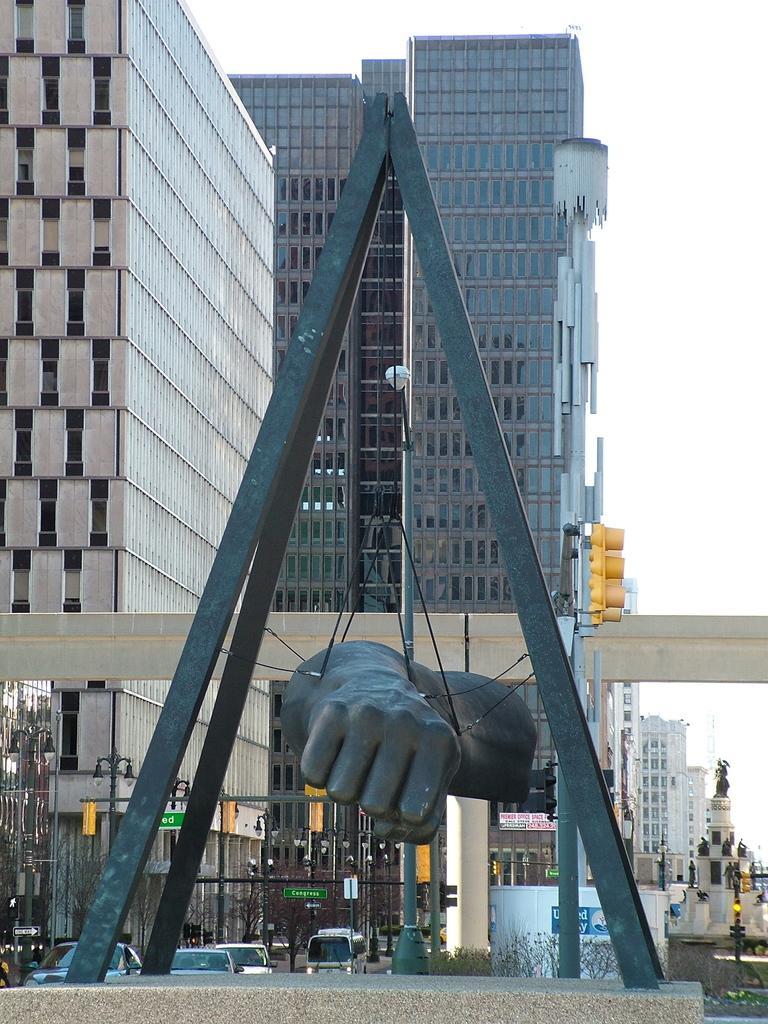Can you describe this image briefly? In this image we can see poles. There is a statue of a hand is hanged with ropes on the poles. In the background there are buildings. Also there are vehicles, light poles and plants. And there is sky. And we can see a traffic signals. 